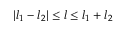Convert formula to latex. <formula><loc_0><loc_0><loc_500><loc_500>| l _ { 1 } - l _ { 2 } | \leq l \leq l _ { 1 } + l _ { 2 }</formula> 